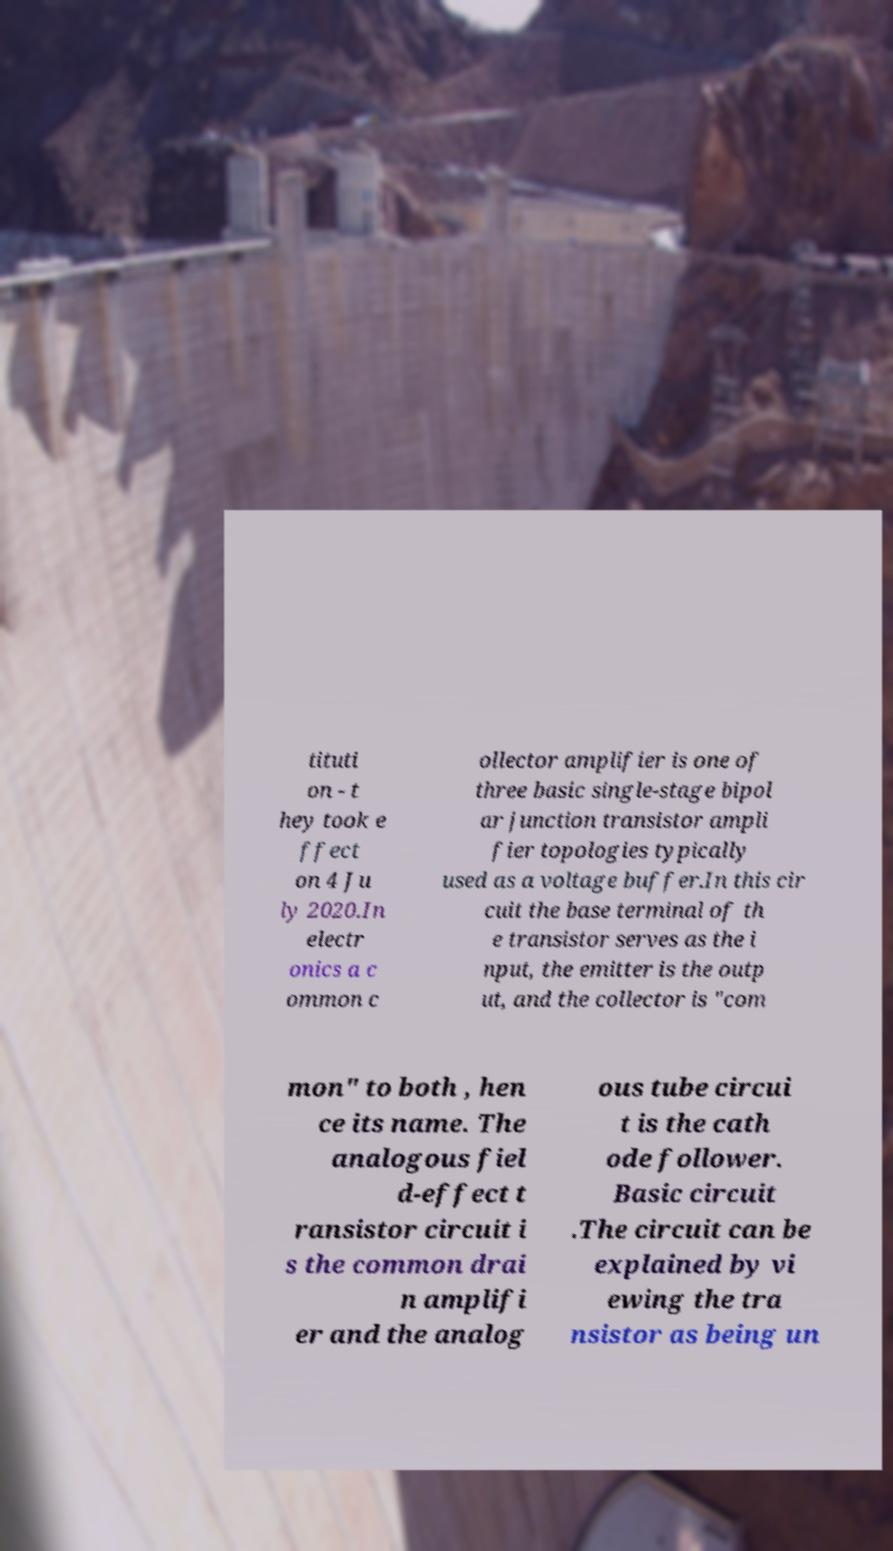There's text embedded in this image that I need extracted. Can you transcribe it verbatim? tituti on - t hey took e ffect on 4 Ju ly 2020.In electr onics a c ommon c ollector amplifier is one of three basic single-stage bipol ar junction transistor ampli fier topologies typically used as a voltage buffer.In this cir cuit the base terminal of th e transistor serves as the i nput, the emitter is the outp ut, and the collector is "com mon" to both , hen ce its name. The analogous fiel d-effect t ransistor circuit i s the common drai n amplifi er and the analog ous tube circui t is the cath ode follower. Basic circuit .The circuit can be explained by vi ewing the tra nsistor as being un 